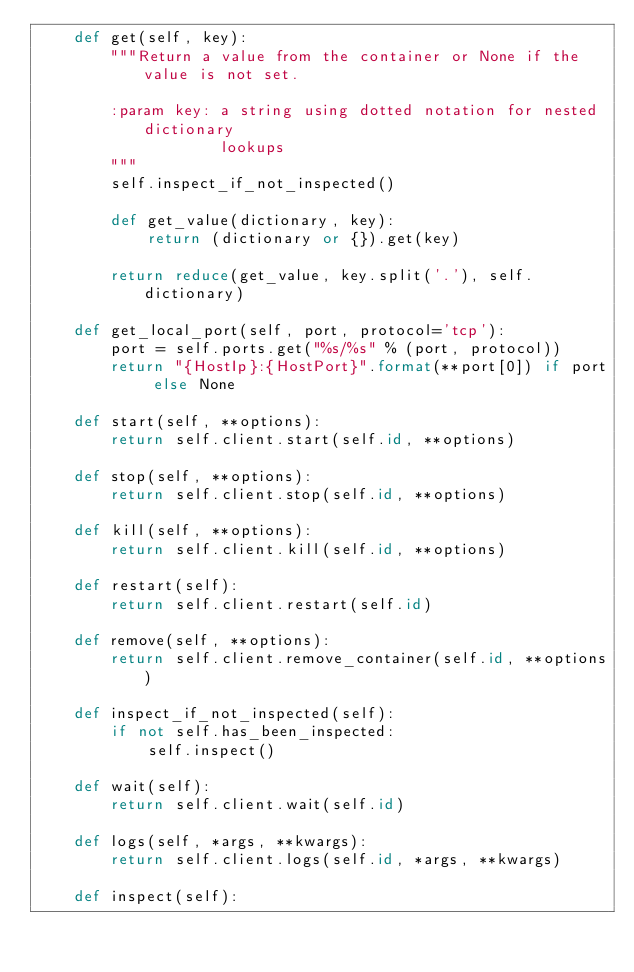<code> <loc_0><loc_0><loc_500><loc_500><_Python_>    def get(self, key):
        """Return a value from the container or None if the value is not set.

        :param key: a string using dotted notation for nested dictionary
                    lookups
        """
        self.inspect_if_not_inspected()

        def get_value(dictionary, key):
            return (dictionary or {}).get(key)

        return reduce(get_value, key.split('.'), self.dictionary)

    def get_local_port(self, port, protocol='tcp'):
        port = self.ports.get("%s/%s" % (port, protocol))
        return "{HostIp}:{HostPort}".format(**port[0]) if port else None

    def start(self, **options):
        return self.client.start(self.id, **options)

    def stop(self, **options):
        return self.client.stop(self.id, **options)

    def kill(self, **options):
        return self.client.kill(self.id, **options)

    def restart(self):
        return self.client.restart(self.id)

    def remove(self, **options):
        return self.client.remove_container(self.id, **options)

    def inspect_if_not_inspected(self):
        if not self.has_been_inspected:
            self.inspect()

    def wait(self):
        return self.client.wait(self.id)

    def logs(self, *args, **kwargs):
        return self.client.logs(self.id, *args, **kwargs)

    def inspect(self):</code> 